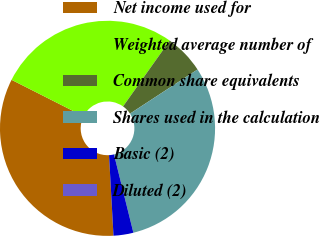Convert chart to OTSL. <chart><loc_0><loc_0><loc_500><loc_500><pie_chart><fcel>Net income used for<fcel>Weighted average number of<fcel>Common share equivalents<fcel>Shares used in the calculation<fcel>Basic (2)<fcel>Diluted (2)<nl><fcel>33.33%<fcel>27.36%<fcel>5.97%<fcel>30.35%<fcel>2.98%<fcel>0.0%<nl></chart> 